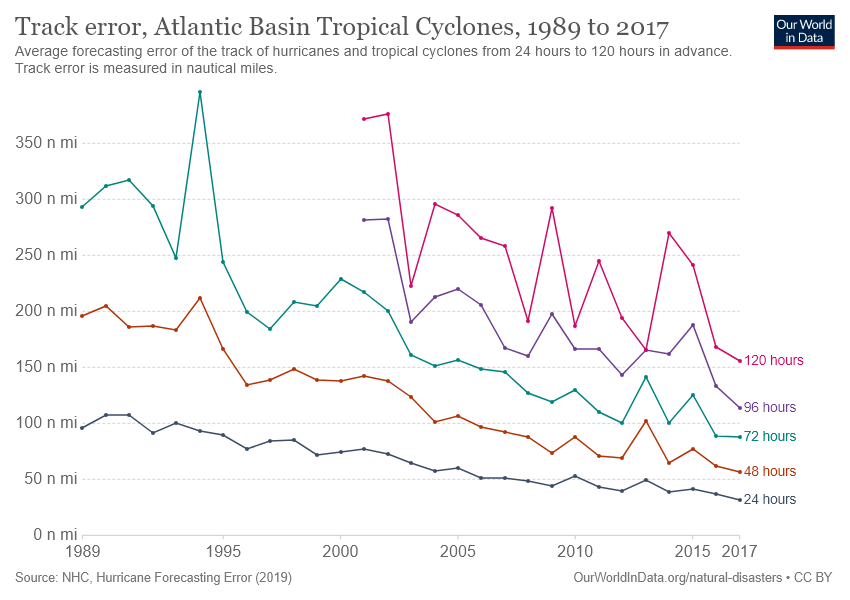Mention a couple of crucial points in this snapshot. In 1995, the 72-hour line had its highest value. After 24 hours, the line with the lowest track error has been achieved. 